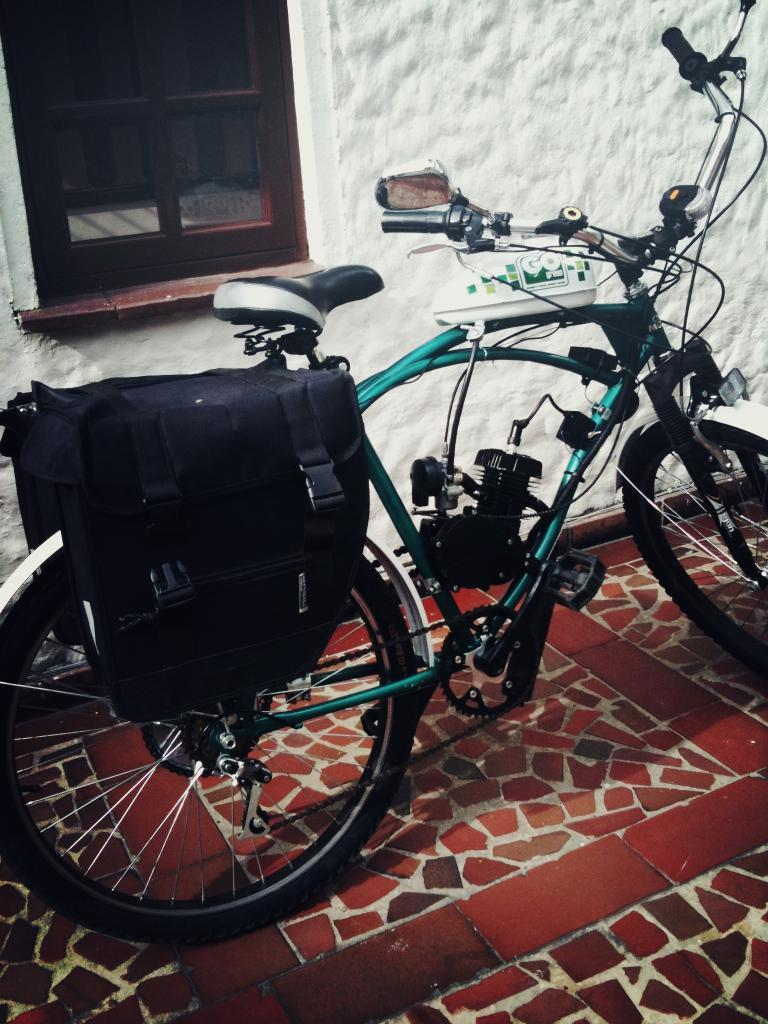What is the main object in the image? There is a bicycle in the image. Where is the bicycle located? The bicycle is on the floor. Is there anything attached to the bicycle? Yes, there is a bag on the bicycle. What can be seen behind the bicycle? There is a wall with a window behind the bicycle. What type of toy is being docked in the event shown in the image? There is no toy or event present in the image; it features a bicycle on the floor with a bag and a wall with a window behind it. 